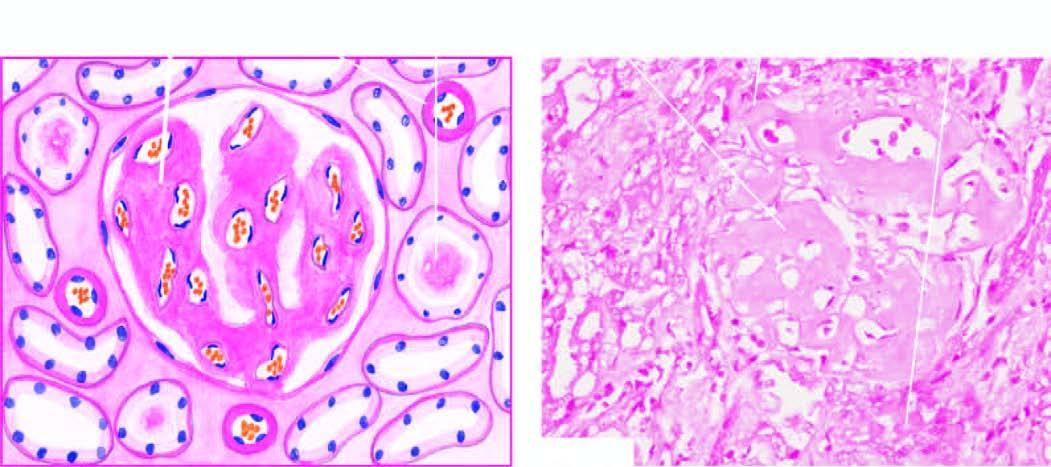re the amyloid deposits seen mainly in the glomerular capillary tuft?
Answer the question using a single word or phrase. Yes 